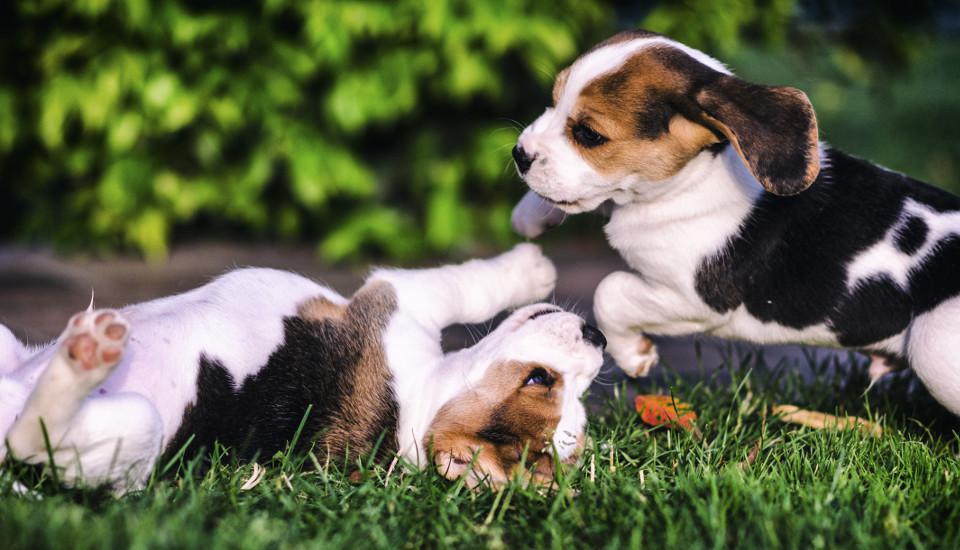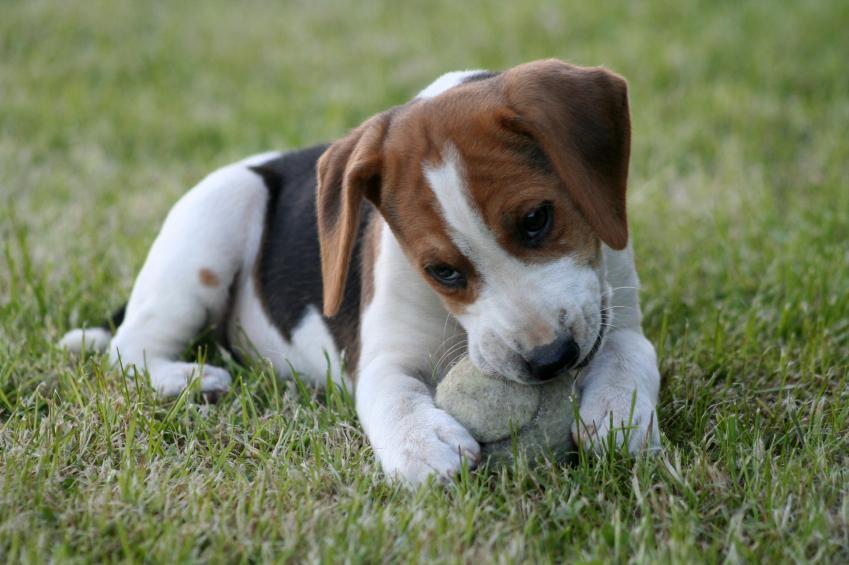The first image is the image on the left, the second image is the image on the right. Considering the images on both sides, is "there is a dog  with a ball in its mouth on a grassy lawn" valid? Answer yes or no. Yes. The first image is the image on the left, the second image is the image on the right. Evaluate the accuracy of this statement regarding the images: "There are 3 or more puppies playing outside.". Is it true? Answer yes or no. Yes. 